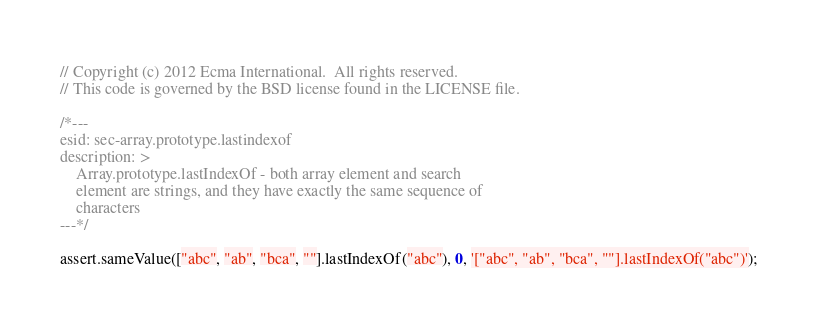Convert code to text. <code><loc_0><loc_0><loc_500><loc_500><_JavaScript_>// Copyright (c) 2012 Ecma International.  All rights reserved.
// This code is governed by the BSD license found in the LICENSE file.

/*---
esid: sec-array.prototype.lastindexof
description: >
    Array.prototype.lastIndexOf - both array element and search
    element are strings, and they have exactly the same sequence of
    characters
---*/

assert.sameValue(["abc", "ab", "bca", ""].lastIndexOf("abc"), 0, '["abc", "ab", "bca", ""].lastIndexOf("abc")');
</code> 